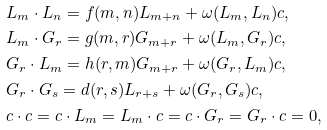Convert formula to latex. <formula><loc_0><loc_0><loc_500><loc_500>& L _ { m } \cdot L _ { n } = f ( m , n ) L _ { m + n } + \omega ( L _ { m } , L _ { n } ) c , \\ & L _ { m } \cdot G _ { r } = g ( m , r ) G _ { m + r } + \omega ( L _ { m } , G _ { r } ) c , \\ & G _ { r } \cdot L _ { m } = h ( r , m ) G _ { m + r } + \omega ( G _ { r } , L _ { m } ) c , \\ & G _ { r } \cdot G _ { s } = d ( r , s ) L _ { r + s } + \omega ( G _ { r } , G _ { s } ) c , \\ & c \cdot c = c \cdot L _ { m } = L _ { m } \cdot c = c \cdot G _ { r } = G _ { r } \cdot c = 0 ,</formula> 